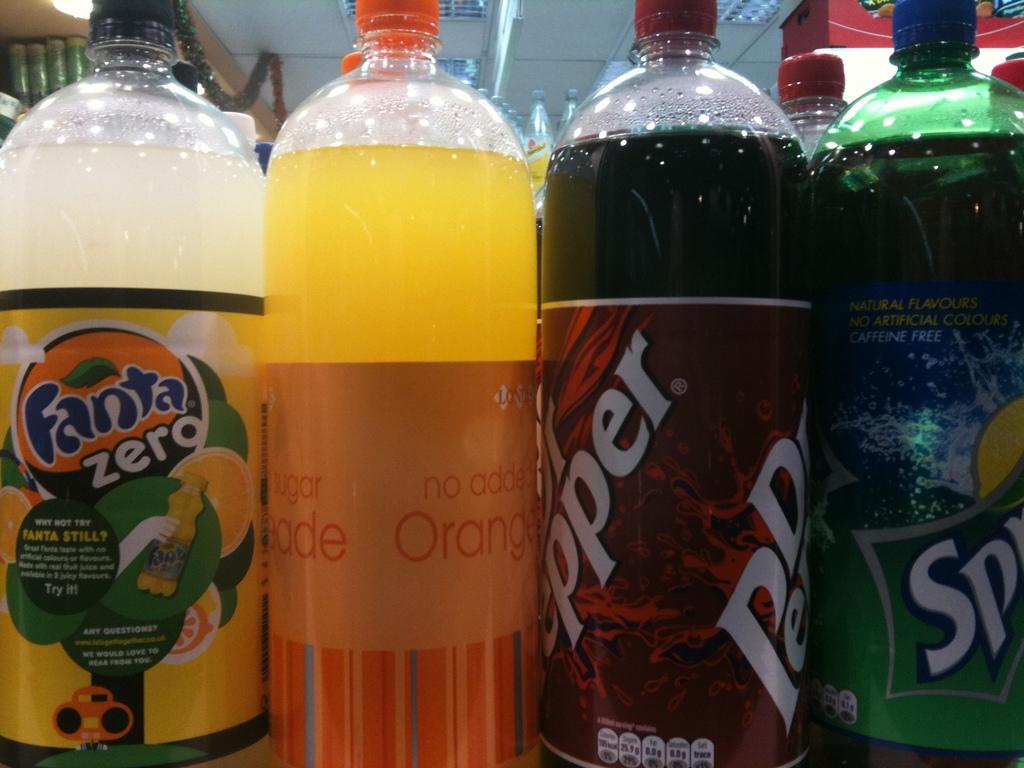What type of fanta is it?
Offer a very short reply. Zero. What fruit is the striped bottle flavored with?
Keep it short and to the point. Orange. 